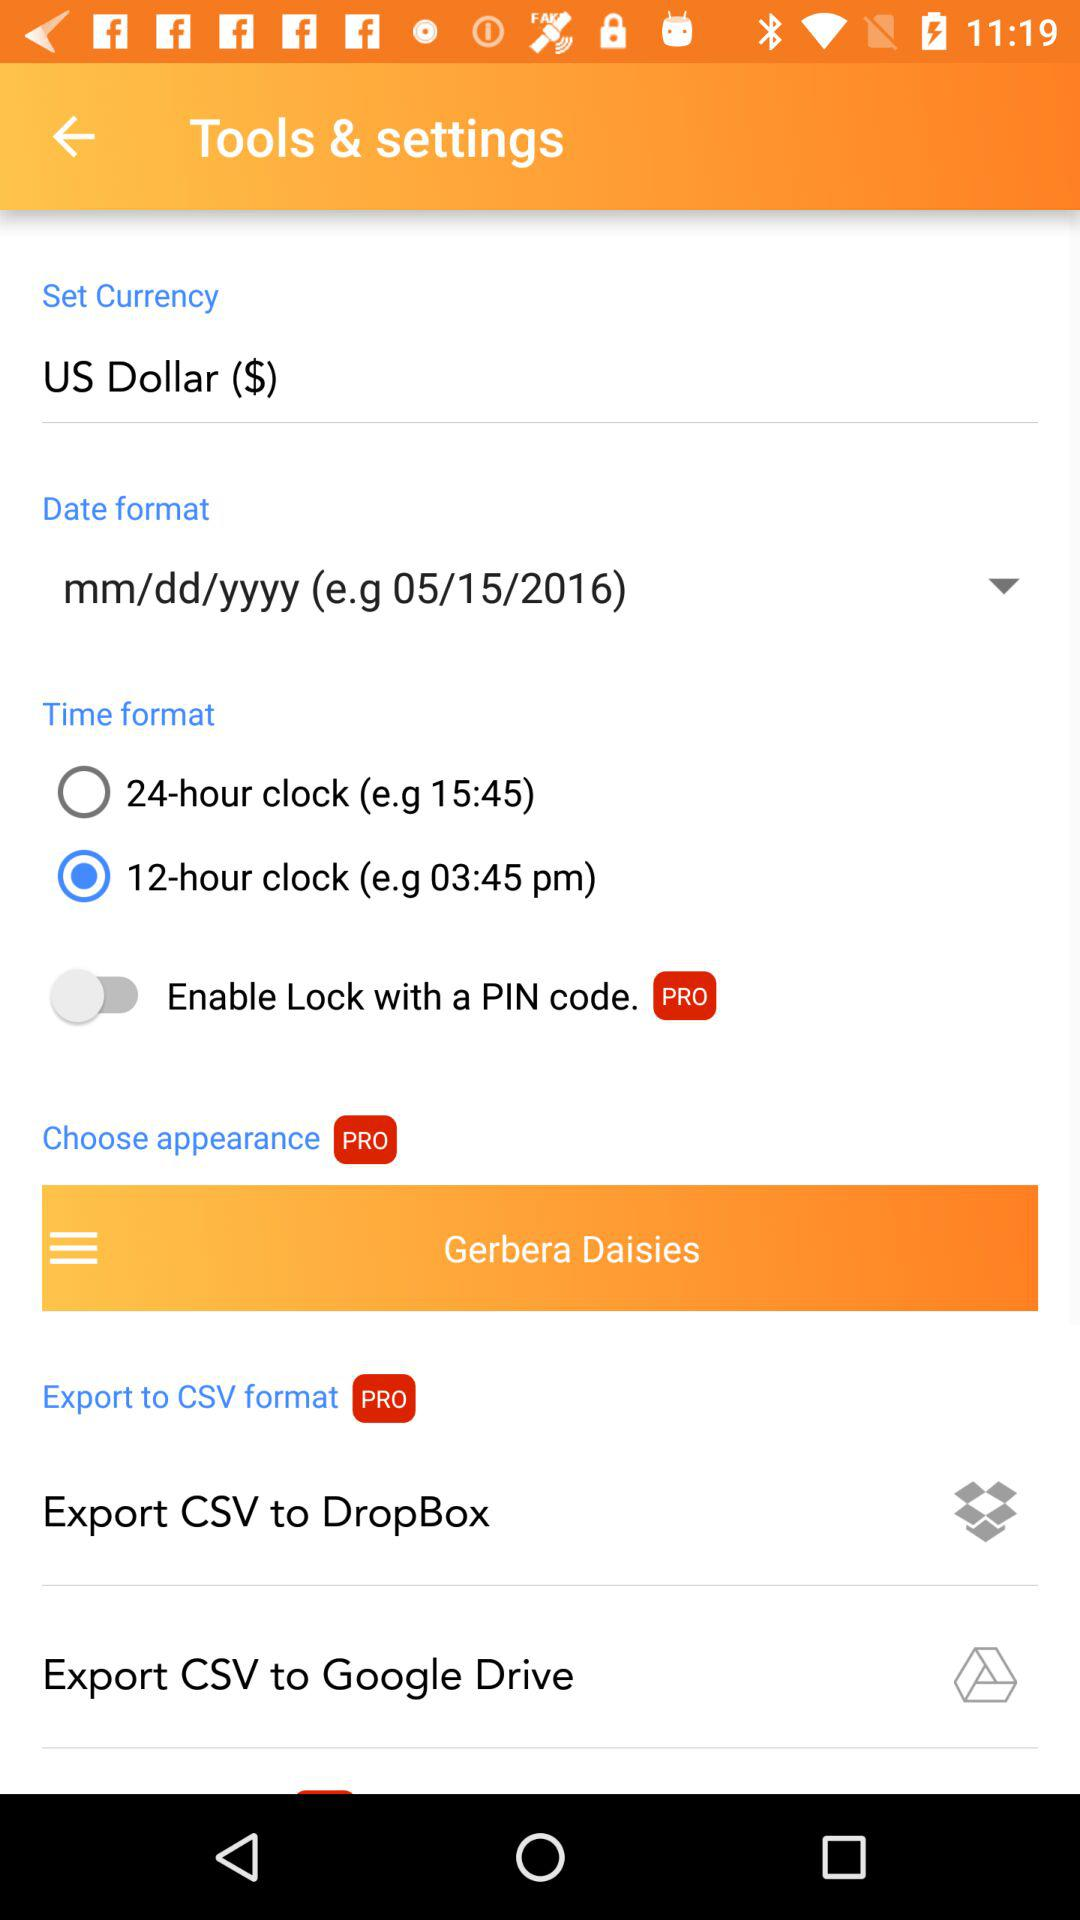Which time format is selected? The selected time format is "12-hour clock". 